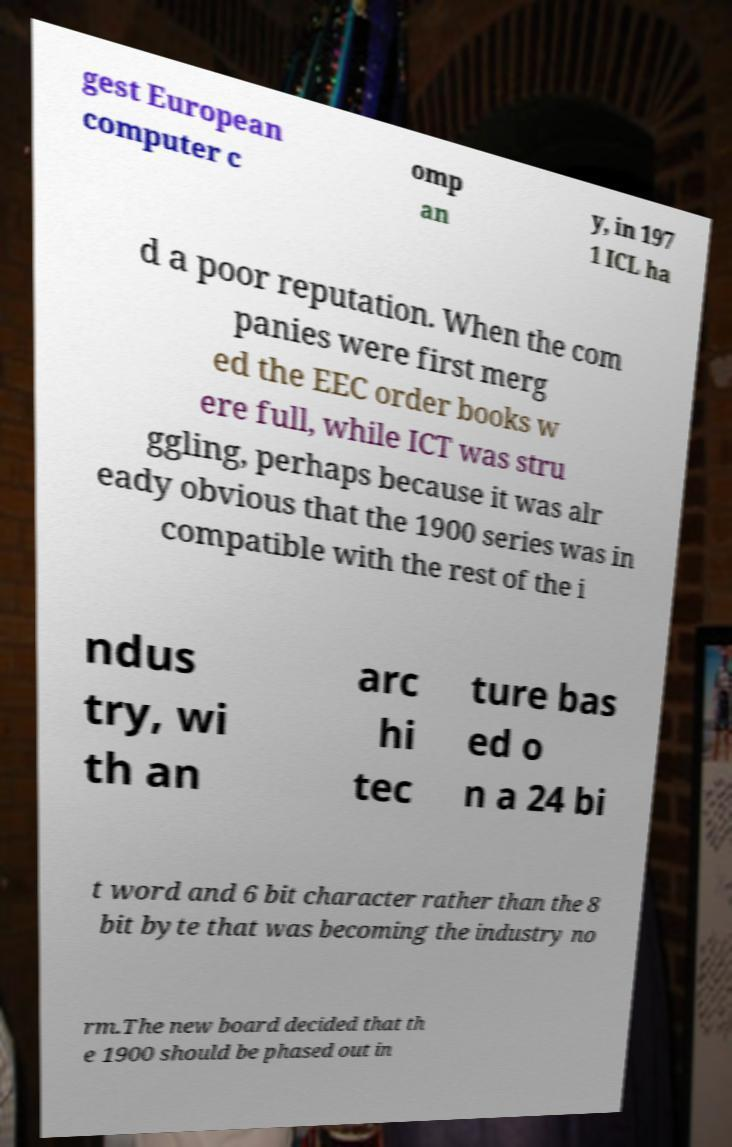There's text embedded in this image that I need extracted. Can you transcribe it verbatim? gest European computer c omp an y, in 197 1 ICL ha d a poor reputation. When the com panies were first merg ed the EEC order books w ere full, while ICT was stru ggling, perhaps because it was alr eady obvious that the 1900 series was in compatible with the rest of the i ndus try, wi th an arc hi tec ture bas ed o n a 24 bi t word and 6 bit character rather than the 8 bit byte that was becoming the industry no rm.The new board decided that th e 1900 should be phased out in 